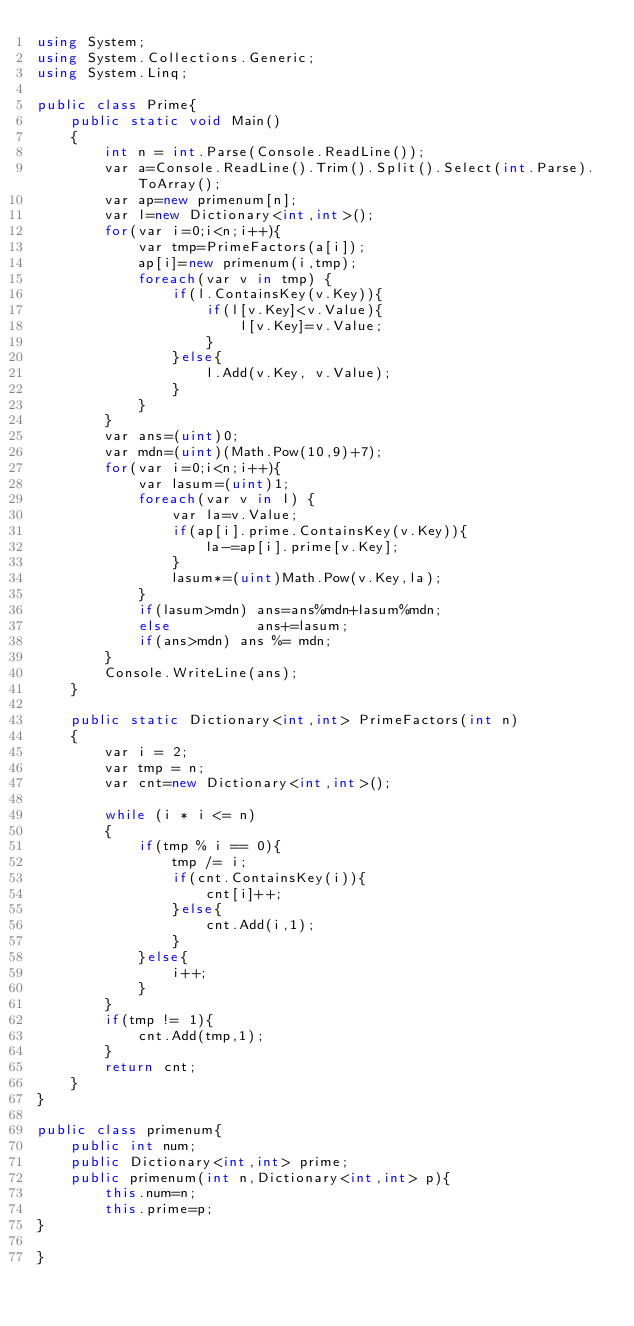Convert code to text. <code><loc_0><loc_0><loc_500><loc_500><_C#_>using System;
using System.Collections.Generic;
using System.Linq;

public class Prime{
    public static void Main()
    {
        int n = int.Parse(Console.ReadLine());
        var a=Console.ReadLine().Trim().Split().Select(int.Parse).ToArray();
        var ap=new primenum[n];
        var l=new Dictionary<int,int>();
        for(var i=0;i<n;i++){
            var tmp=PrimeFactors(a[i]);
            ap[i]=new primenum(i,tmp);
            foreach(var v in tmp) {
                if(l.ContainsKey(v.Key)){
                    if(l[v.Key]<v.Value){
                        l[v.Key]=v.Value;
                    }
                }else{
                    l.Add(v.Key, v.Value);
                }
            }
        }
        var ans=(uint)0;
        var mdn=(uint)(Math.Pow(10,9)+7);
        for(var i=0;i<n;i++){
            var lasum=(uint)1;
            foreach(var v in l) {
                var la=v.Value;
                if(ap[i].prime.ContainsKey(v.Key)){
                    la-=ap[i].prime[v.Key];
                }
                lasum*=(uint)Math.Pow(v.Key,la);
            }
            if(lasum>mdn) ans=ans%mdn+lasum%mdn;
            else          ans+=lasum;
            if(ans>mdn) ans %= mdn;
        }
        Console.WriteLine(ans);
    }

    public static Dictionary<int,int> PrimeFactors(int n)
    {
        var i = 2;
        var tmp = n;
        var cnt=new Dictionary<int,int>();

        while (i * i <= n)
        {
            if(tmp % i == 0){
                tmp /= i;
                if(cnt.ContainsKey(i)){
                    cnt[i]++;
                }else{
                    cnt.Add(i,1);
                }
            }else{
                i++;
            }
        }
        if(tmp != 1){
            cnt.Add(tmp,1);
        } 
        return cnt;
    }
}

public class primenum{
    public int num;
    public Dictionary<int,int> prime;
    public primenum(int n,Dictionary<int,int> p){
        this.num=n;
        this.prime=p;
}
    
}</code> 